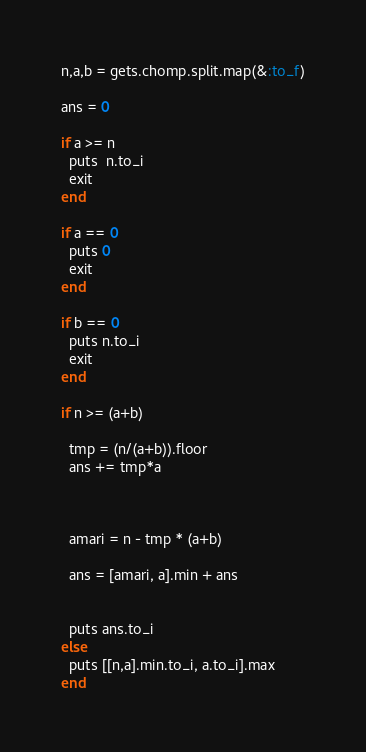Convert code to text. <code><loc_0><loc_0><loc_500><loc_500><_Ruby_>n,a,b = gets.chomp.split.map(&:to_f)

ans = 0

if a >= n
  puts  n.to_i
  exit
end

if a == 0
  puts 0
  exit
end

if b == 0
  puts n.to_i
  exit
end

if n >= (a+b)

  tmp = (n/(a+b)).floor
  ans += tmp*a



  amari = n - tmp * (a+b)

  ans = [amari, a].min + ans


  puts ans.to_i
else
  puts [[n,a].min.to_i, a.to_i].max
end
</code> 